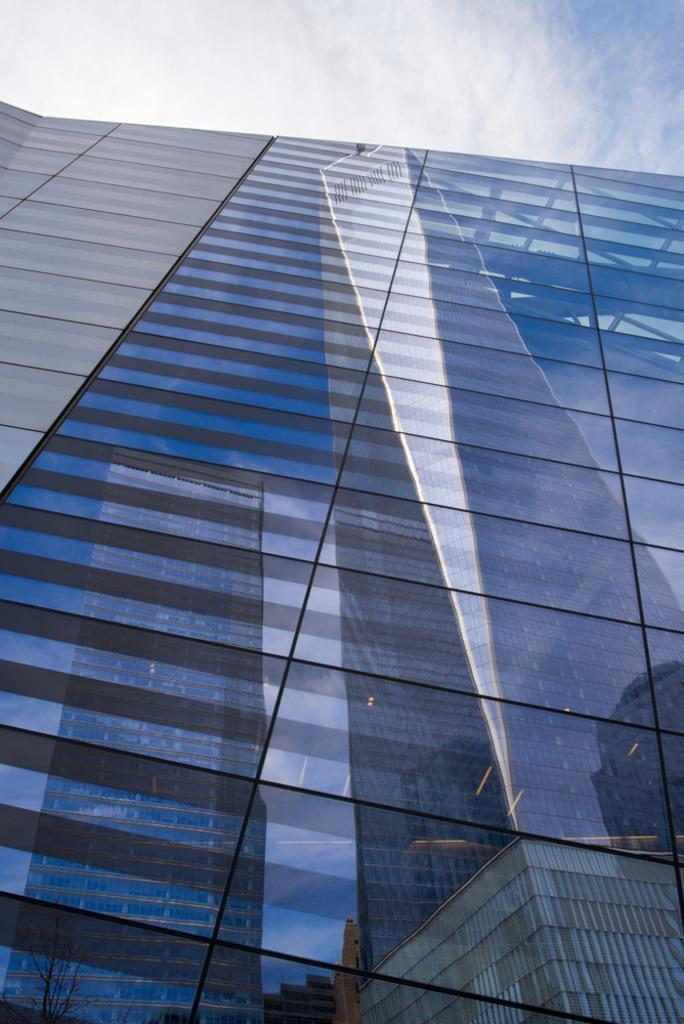What type of building is in the middle of the image? There is a glass building in the middle of the image. What can be seen at the top of the image? The sky is visible at the top of the image. How many chickens are on the island in the image? There is no island or chickens present in the image; it features a glass building and the sky. What type of magic is being performed in the image? There is no magic or magical elements present in the image. 